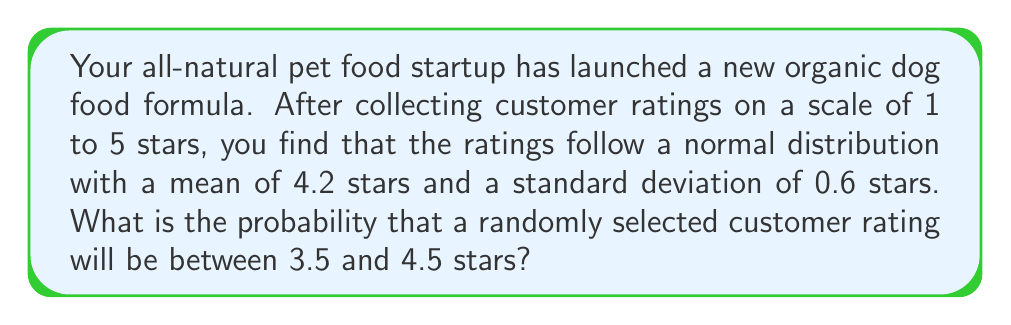Can you solve this math problem? To solve this problem, we need to use the properties of the normal distribution and the concept of z-scores.

1. First, let's identify the given information:
   - The ratings follow a normal distribution
   - Mean (μ) = 4.2 stars
   - Standard deviation (σ) = 0.6 stars
   - We want to find the probability of a rating between 3.5 and 4.5 stars

2. To use the standard normal distribution table, we need to convert the given values to z-scores:

   For 3.5 stars: $z_1 = \frac{3.5 - 4.2}{0.6} = -1.1667$
   For 4.5 stars: $z_2 = \frac{4.5 - 4.2}{0.6} = 0.5$

3. Now, we need to find the area under the standard normal curve between these two z-scores.

4. Using a standard normal distribution table or calculator:
   P(Z < -1.1667) ≈ 0.1217
   P(Z < 0.5) ≈ 0.6915

5. The probability we're looking for is the difference between these two values:
   P(-1.1667 < Z < 0.5) = 0.6915 - 0.1217 = 0.5698

6. Therefore, the probability that a randomly selected customer rating will be between 3.5 and 4.5 stars is approximately 0.5698 or 56.98%.
Answer: The probability that a randomly selected customer rating will be between 3.5 and 4.5 stars is approximately 0.5698 or 56.98%. 